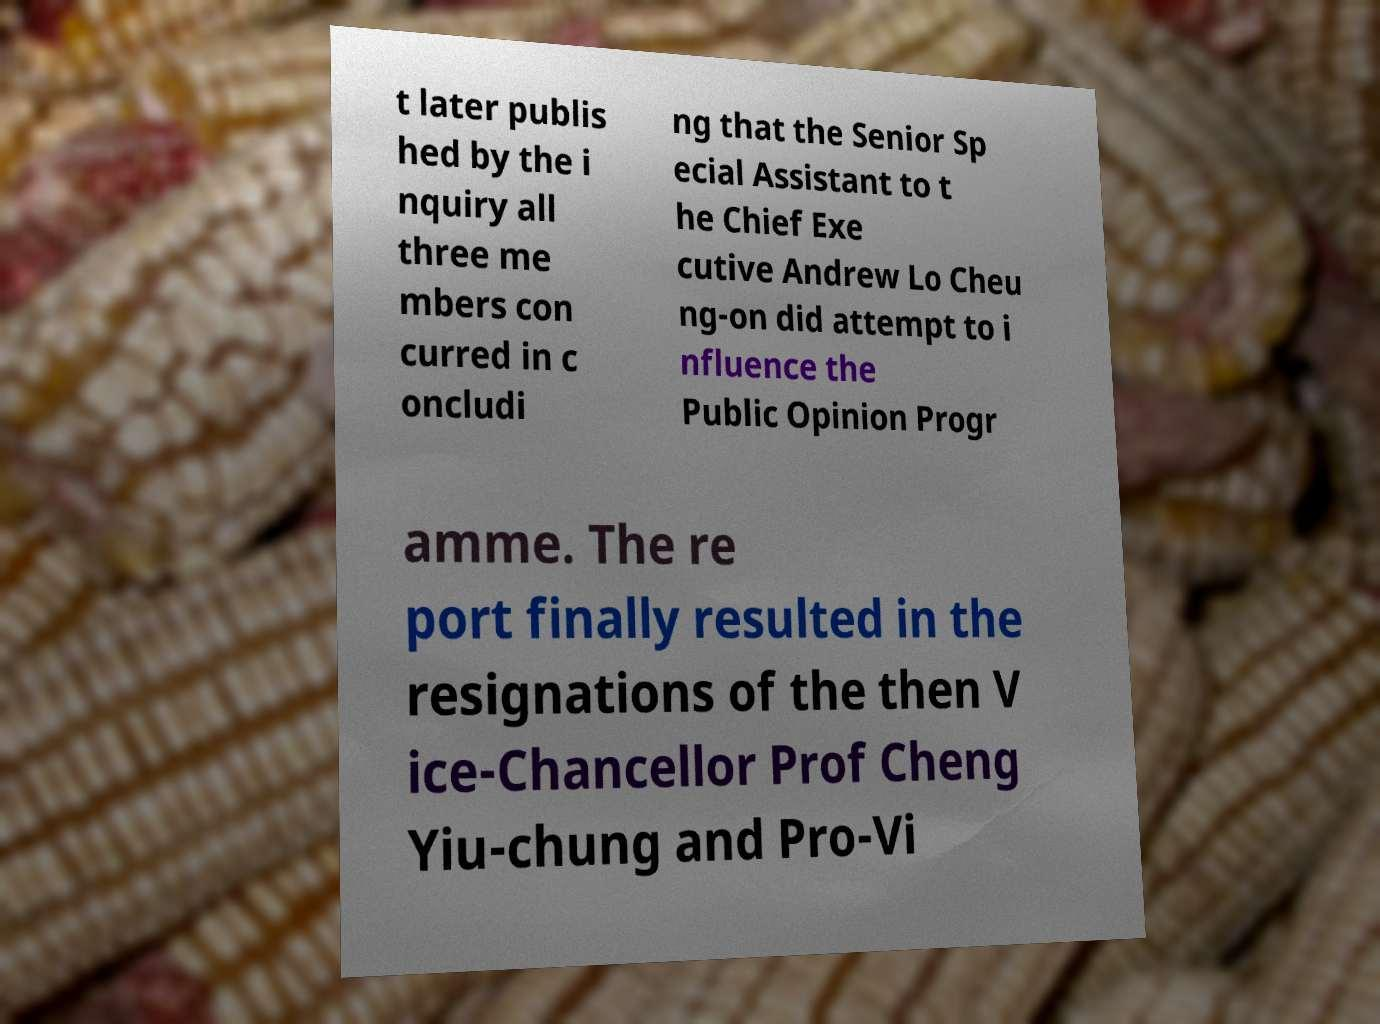Please identify and transcribe the text found in this image. t later publis hed by the i nquiry all three me mbers con curred in c oncludi ng that the Senior Sp ecial Assistant to t he Chief Exe cutive Andrew Lo Cheu ng-on did attempt to i nfluence the Public Opinion Progr amme. The re port finally resulted in the resignations of the then V ice-Chancellor Prof Cheng Yiu-chung and Pro-Vi 